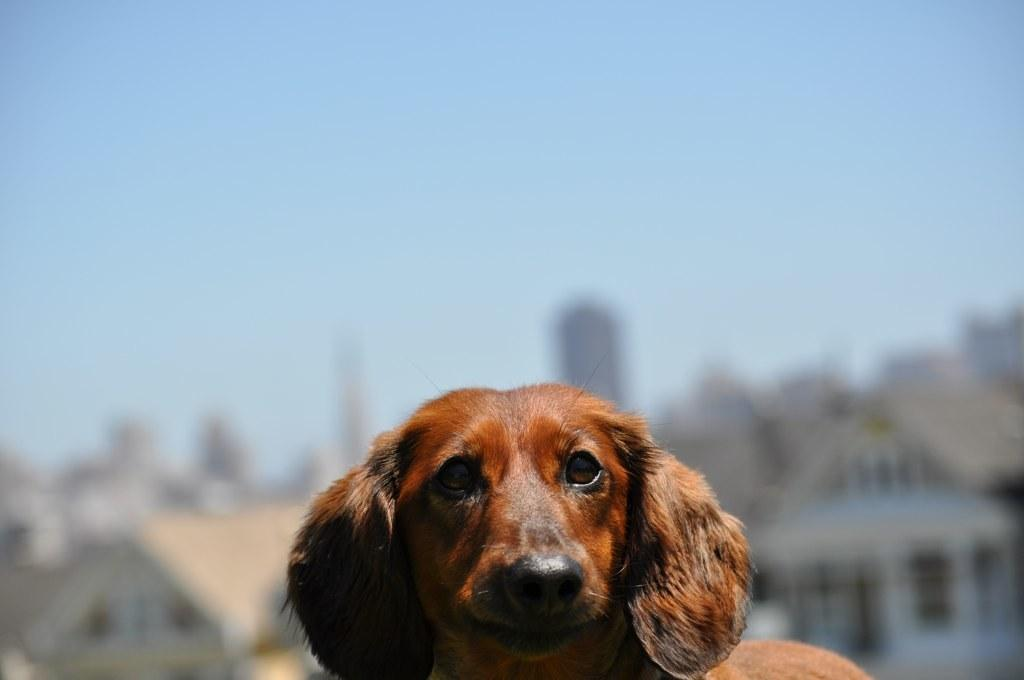What type of animal is in the image? There is a dog in the image. What color is the dog? The dog is brown in color. What can be seen in the distance behind the dog? There are buildings in the background of the image. How is the background of the image depicted? The background is blurred. What type of sound can be heard coming from the loaf in the image? There is no loaf present in the image, and therefore no sound can be heard from it. 